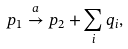Convert formula to latex. <formula><loc_0><loc_0><loc_500><loc_500>p _ { 1 } \stackrel { a } { \to } p _ { 2 } + \sum _ { i } q _ { i } ,</formula> 